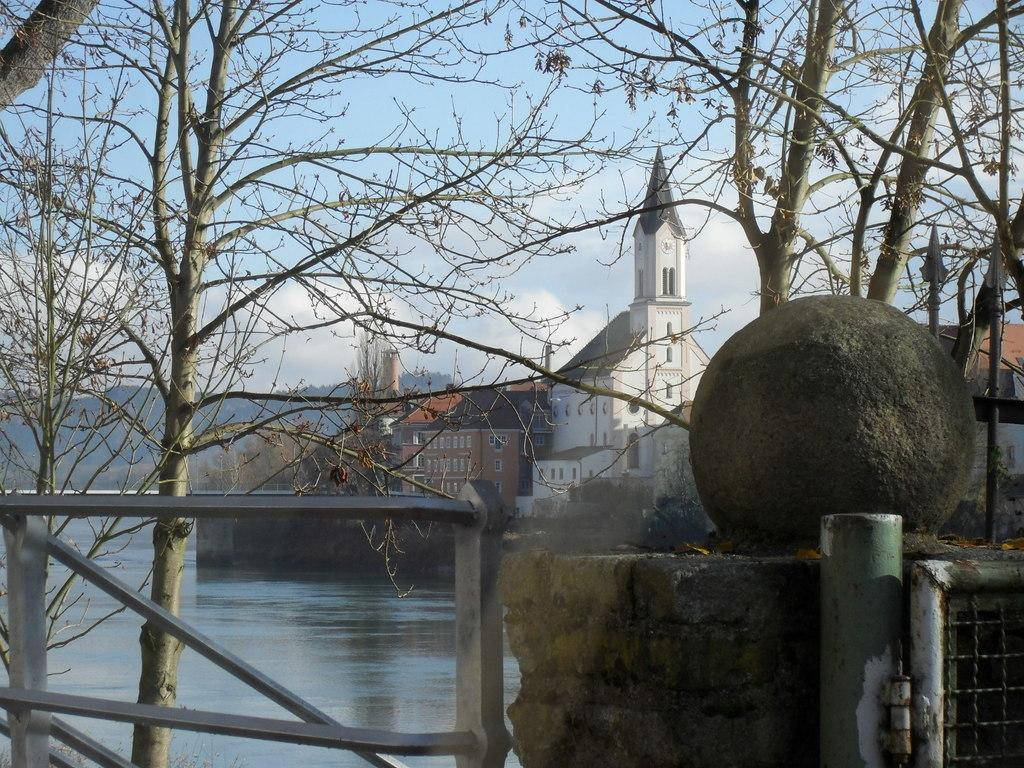What is the main structure visible in the image? There is a pillar in the image. What type of buildings can be seen in the image? There are buildings with windows in the image. What kind of vegetation is present in the image? There are trees with branches in the image. What is the entrance to the area like in the image? There is a gate in the image. What natural element is depicted in the image? Water is flowing in the image. What type of brush is used to paint the religious symbols on the pillar in the image? There are no religious symbols or brushes present in the image; it only features a pillar, buildings, trees, a gate, and flowing water. 